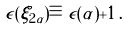Convert formula to latex. <formula><loc_0><loc_0><loc_500><loc_500>\epsilon ( \xi _ { 2 \alpha } ) \equiv \epsilon ( \alpha ) + 1 \, .</formula> 